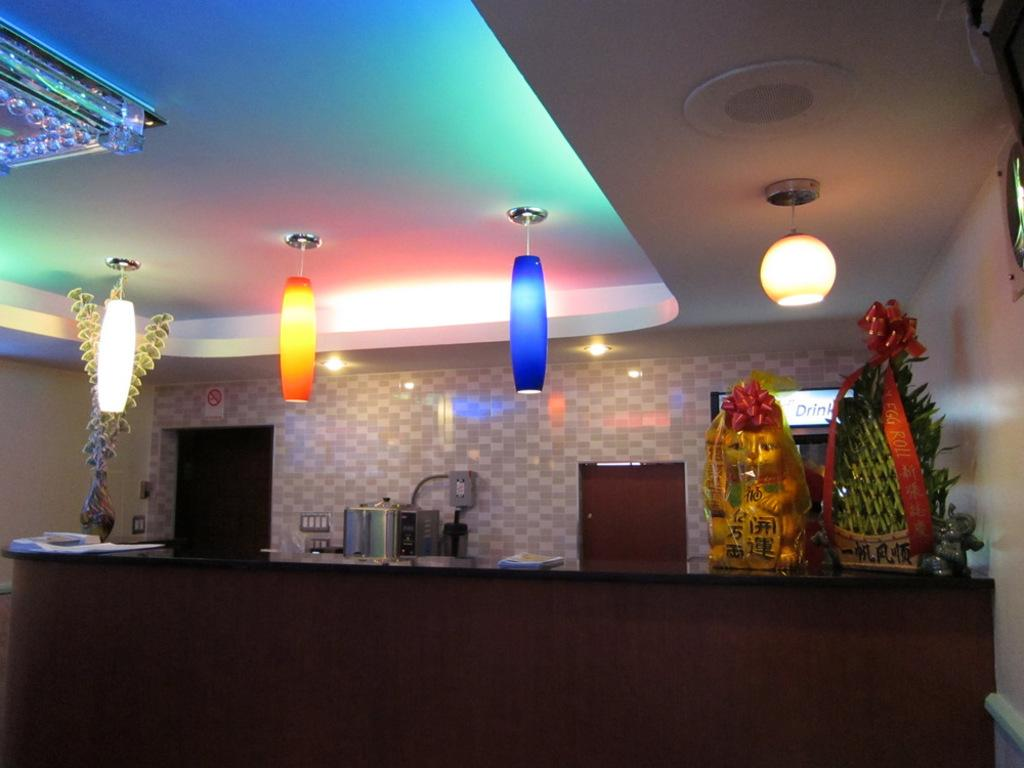What is located in the foreground of the image? There is a cabinet in the foreground of the image. What can be found on the cabinet? Kitchen tools, flower vases, and bouquets are present on the cabinet. How are the lamps positioned in the image? Lamps are hanged on the top of the image. Where was the image taken? The image was taken in a hall. What type of fear can be seen on the cabinet in the image? There is no fear present in the image. The image only contains a cabinet, kitchen tools, flower vases, bouquets, and lamps. 